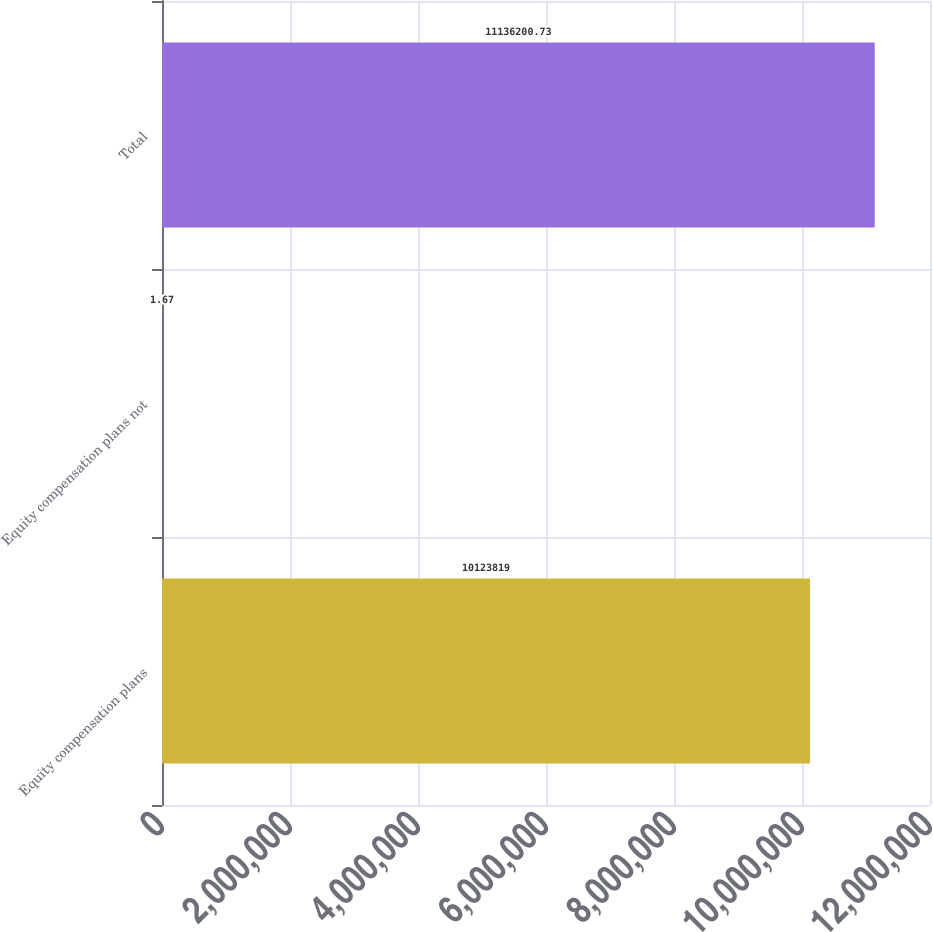<chart> <loc_0><loc_0><loc_500><loc_500><bar_chart><fcel>Equity compensation plans<fcel>Equity compensation plans not<fcel>Total<nl><fcel>1.01238e+07<fcel>1.67<fcel>1.11362e+07<nl></chart> 